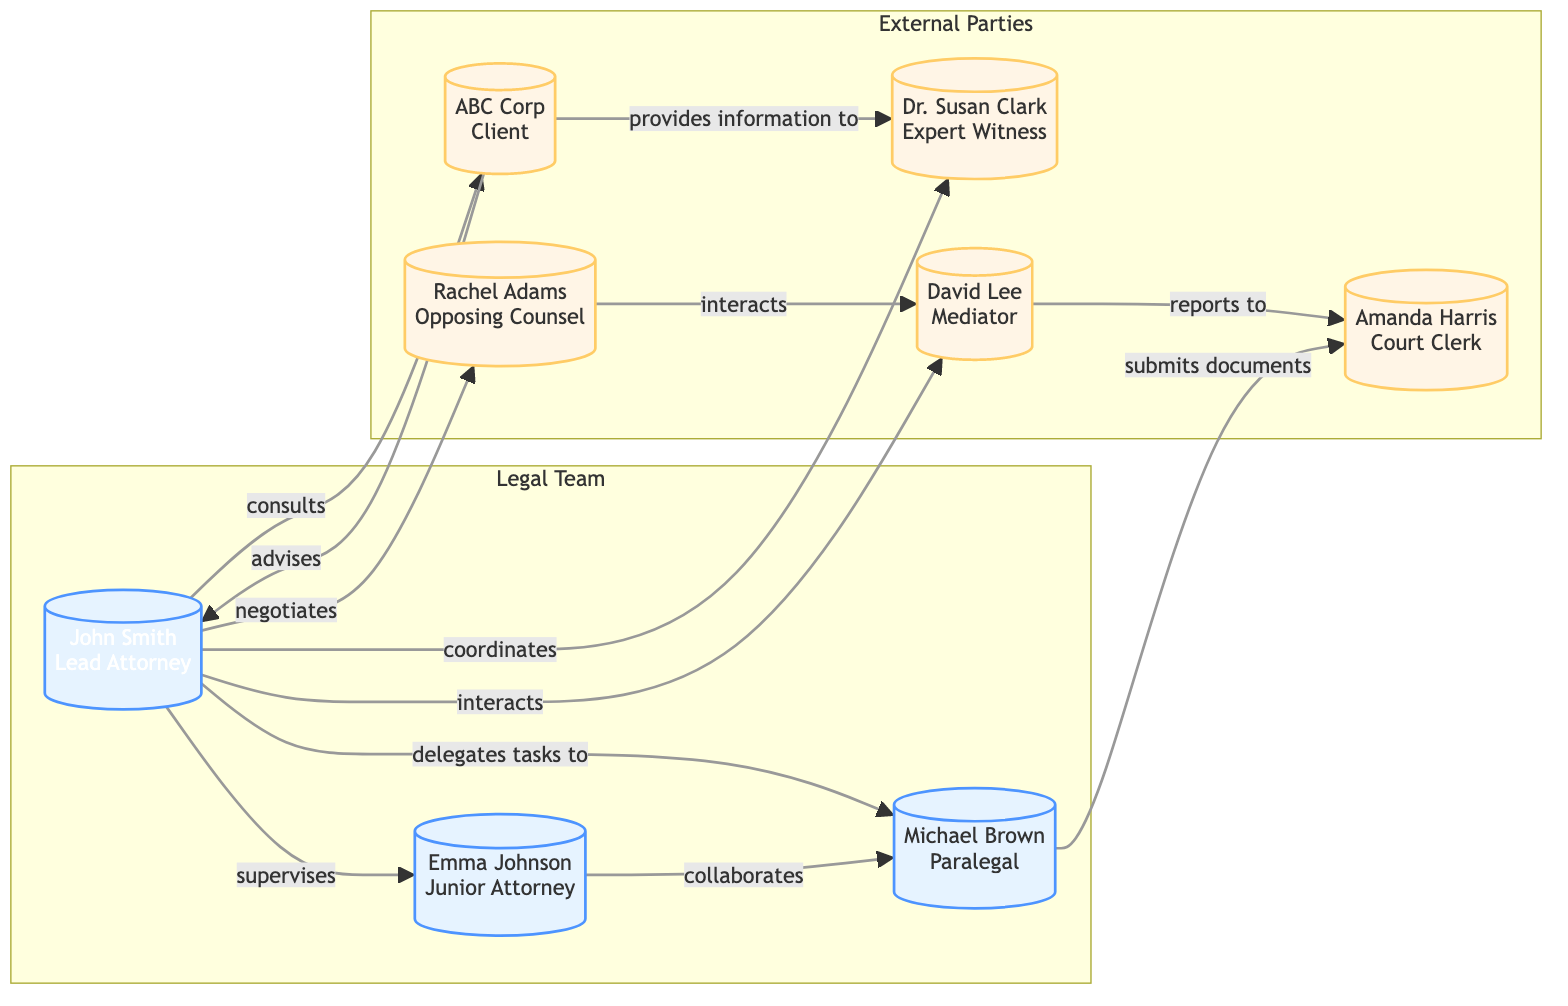What is the total number of nodes in the diagram? The diagram includes eight distinct individuals or entities, each represented as a node. By counting all the listed nodes, we find there are 8 in total.
Answer: 8 Who is supervising the Junior Attorney? In the diagram, the Lead Attorney, John Smith, has a directed relationship labeled "supervises" leading to the Junior Attorney, Emma Johnson. This relationship indicates that John Smith is the supervisor.
Answer: John Smith What task is the Junior Attorney collaborating on? According to the diagram, the Junior Attorney, Emma Johnson, collaborates with the Paralegal, Michael Brown, indicating their joint effort on tasks.
Answer: Michael Brown How many relationships does the Lead Attorney have in total? By examining the edges connected to the Lead Attorney, we can see that there are six relationships extending from John Smith to other parties. Counting these connections, we conclude there are 6.
Answer: 6 What is the relationship between the Client and the Lead Attorney? The Client, ABC Corp, has a directed edge labeled "advises" connecting to the Lead Attorney, John Smith, indicating a consultative relationship.
Answer: advises Which party does the Mediator report to? In the diagram, the Mediator, David Lee, has a directed edge labeled "reports to" leading to the Court Clerk, Amanda Harris, representing their reporting relationship.
Answer: Amanda Harris Who are the external parties involved in this collaboration network? The external parties are the entities that do not belong to the legal team group. The diagram lists ABC Corp as the Client, Dr. Susan Clark as the Expert Witness, Rachel Adams as the Opposing Counsel, David Lee as the Mediator, and Amanda Harris as the Court Clerk, totaling five external parties.
Answer: ABC Corp, Dr. Susan Clark, Rachel Adams, David Lee, Amanda Harris What type of relationship exists between the Opposing Counsel and the Mediator? The diagram indicates that the Opposing Counsel, Rachel Adams, interacts with the Mediator, David Lee, signifying a communicative or collaborative relationship.
Answer: interacts How does the Paralegal interact with the Court Clerk? The diagram shows that the Paralegal, Michael Brown, submits documents to the Court Clerk, Amanda Harris, indicating a procedural relationship.
Answer: submits documents 